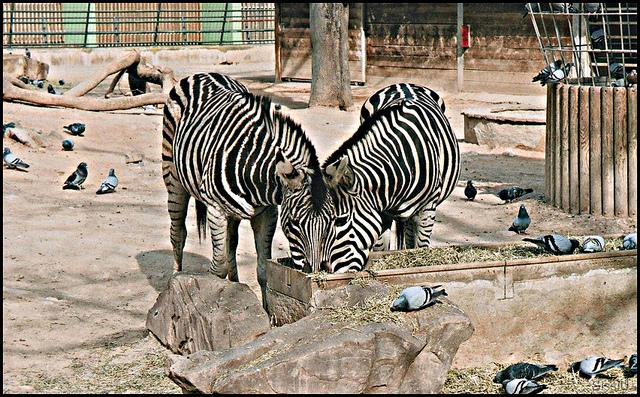How many zebras are eating hay from the trough? Please explain your reasoning. two. There are two zebras. 